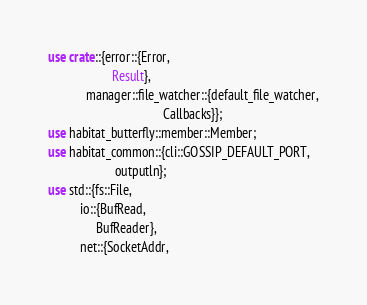Convert code to text. <code><loc_0><loc_0><loc_500><loc_500><_Rust_>use crate::{error::{Error,
                    Result},
            manager::file_watcher::{default_file_watcher,
                                    Callbacks}};
use habitat_butterfly::member::Member;
use habitat_common::{cli::GOSSIP_DEFAULT_PORT,
                     outputln};
use std::{fs::File,
          io::{BufRead,
               BufReader},
          net::{SocketAddr,</code> 